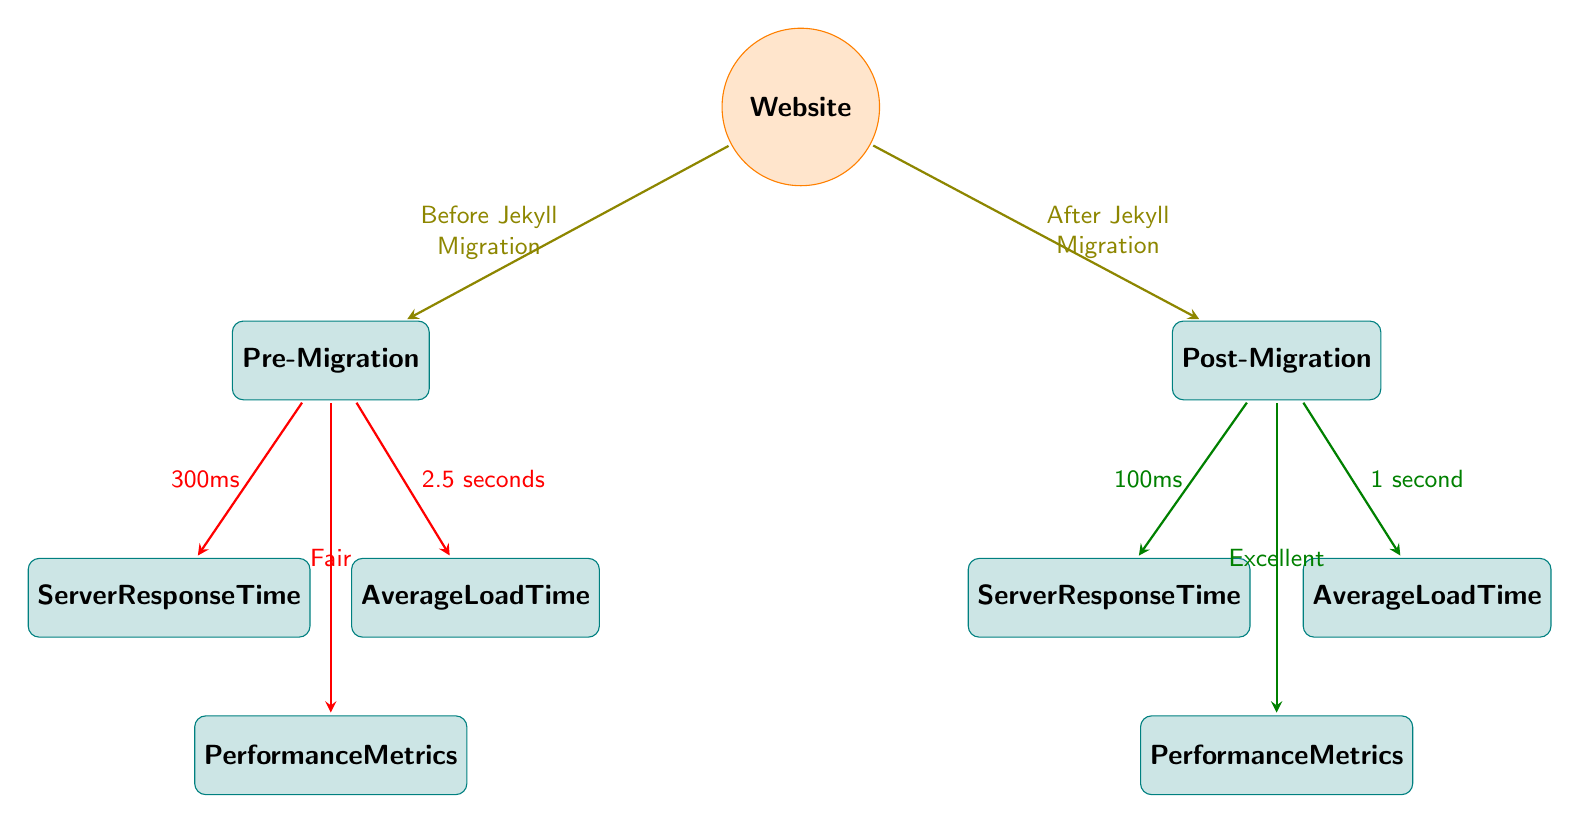What is the average server response time before migration? According to the diagram, the average server response time before migration is indicated as approximately 300 milliseconds. This value is connected to the "Pre-Migration" box through an olive arrow leading to the "Server Response Time" node.
Answer: ~300ms What is the performance metric after migration? The diagram indicates that the performance metric after migration is categorized as "Excellent." This information can be found in the "Post-Migration" box, specifically within the "Performance Metrics" node, connected by a green arrow.
Answer: Excellent What is the average load time after migration? The diagram shows that the average load time after migration is stated as approximately 1 second. This value is indicated in the "Post-Migration" box, connected by a green arrow to the "Average Load Time" node.
Answer: ~1 second How many performance metrics nodes are shown in the diagram? The diagram presents two performance metrics nodes: one for the "Pre-Migration" and another for the "Post-Migration." By counting the corresponding nodes, we identify there are two distinct metrics.
Answer: 2 What can be inferred about the pre-migration performance metrics? The performance metrics before migration are classified as "Fair." This inference is drawn from the direct labeling in the "Pre-Migration" box under the "Performance Metrics" node connected by an olive arrow.
Answer: Fair What change occurs in server response time from before to after migration? The diagram illustrates a significant reduction in server response time, decreasing from approximately 300 milliseconds before migration to approximately 100 milliseconds after migration. This comparison can be derived by evaluating the values connected to the "Server Response Time" nodes in each migration phase.
Answer: ~200ms reduction What color represents the post-migration performance metrics? The post-migration performance metrics are represented in green, as indicated by the color of the arrows connecting the "Post-Migration" box to its respective nodes. This usage of color denotes the positive performance after migration.
Answer: Green What does an average load time of 2.5 seconds suggest about pre-migration performance? The average load time of 2.5 seconds before migration suggests a relatively slow performance level. This value, indicated in the "Pre-Migration" box, serves as a direct measure of the site's efficiency prior to the transition to Jekyll.
Answer: Slow performance 